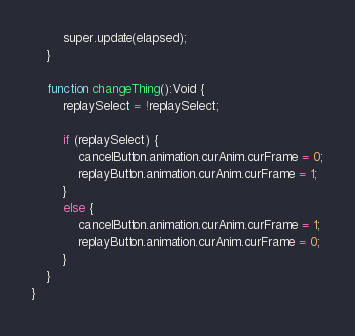Convert code to text. <code><loc_0><loc_0><loc_500><loc_500><_Haxe_>
		super.update(elapsed);
	}

	function changeThing():Void {
		replaySelect = !replaySelect;

		if (replaySelect) {
			cancelButton.animation.curAnim.curFrame = 0;
			replayButton.animation.curAnim.curFrame = 1;
		}
		else {
			cancelButton.animation.curAnim.curFrame = 1;
			replayButton.animation.curAnim.curFrame = 0;
		}
	}
}
</code> 